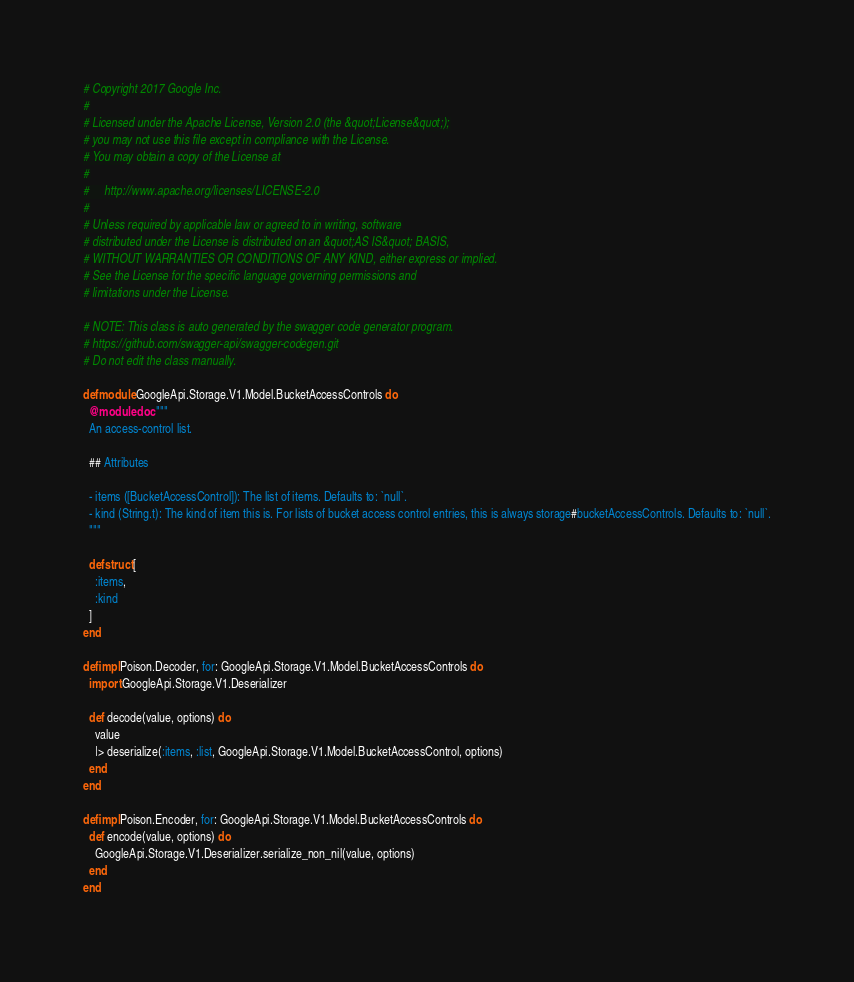<code> <loc_0><loc_0><loc_500><loc_500><_Elixir_># Copyright 2017 Google Inc.
#
# Licensed under the Apache License, Version 2.0 (the &quot;License&quot;);
# you may not use this file except in compliance with the License.
# You may obtain a copy of the License at
#
#     http://www.apache.org/licenses/LICENSE-2.0
#
# Unless required by applicable law or agreed to in writing, software
# distributed under the License is distributed on an &quot;AS IS&quot; BASIS,
# WITHOUT WARRANTIES OR CONDITIONS OF ANY KIND, either express or implied.
# See the License for the specific language governing permissions and
# limitations under the License.

# NOTE: This class is auto generated by the swagger code generator program.
# https://github.com/swagger-api/swagger-codegen.git
# Do not edit the class manually.

defmodule GoogleApi.Storage.V1.Model.BucketAccessControls do
  @moduledoc """
  An access-control list.

  ## Attributes

  - items ([BucketAccessControl]): The list of items. Defaults to: `null`.
  - kind (String.t): The kind of item this is. For lists of bucket access control entries, this is always storage#bucketAccessControls. Defaults to: `null`.
  """

  defstruct [
    :items,
    :kind
  ]
end

defimpl Poison.Decoder, for: GoogleApi.Storage.V1.Model.BucketAccessControls do
  import GoogleApi.Storage.V1.Deserializer

  def decode(value, options) do
    value
    |> deserialize(:items, :list, GoogleApi.Storage.V1.Model.BucketAccessControl, options)
  end
end

defimpl Poison.Encoder, for: GoogleApi.Storage.V1.Model.BucketAccessControls do
  def encode(value, options) do
    GoogleApi.Storage.V1.Deserializer.serialize_non_nil(value, options)
  end
end
</code> 